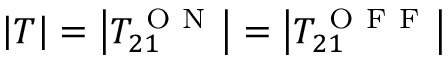<formula> <loc_0><loc_0><loc_500><loc_500>\left | T \right | = \left | T _ { 2 1 } ^ { O N } \right | = \left | T _ { 2 1 } ^ { O F F } \right |</formula> 